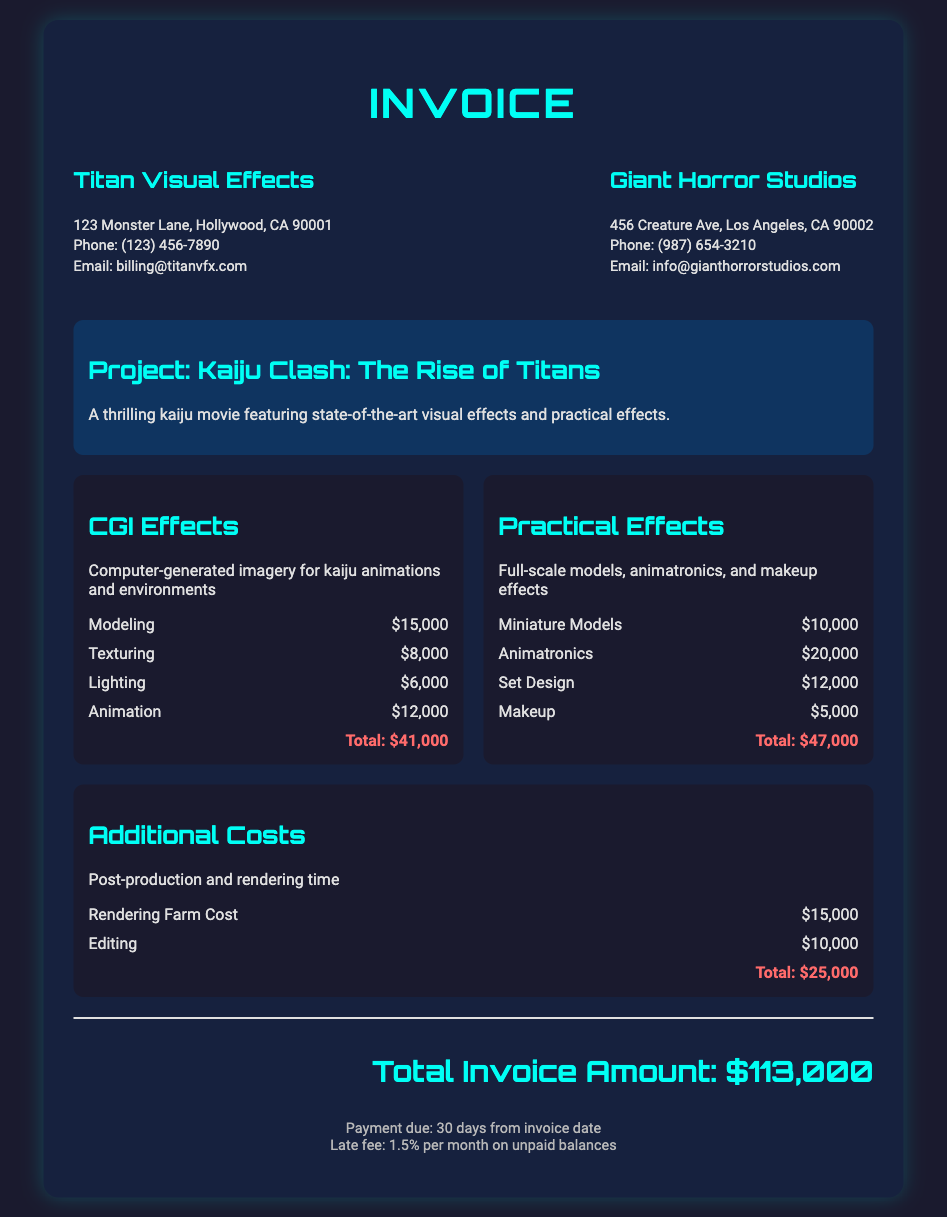What is the total amount for CGI effects? The total amount for CGI effects is stated in the cost category, which is $41,000.
Answer: $41,000 What is the name of the project? The project name is mentioned in the project information section as "Kaiju Clash: The Rise of Titans."
Answer: Kaiju Clash: The Rise of Titans How much was spent on animatronics? The amount spent on animatronics is listed under practical effects, which is $20,000.
Answer: $20,000 What is the grand total of the invoice? The grand total is found in the grand total section of the invoice, which sums up all costs to $113,000.
Answer: $113,000 What is the payment due period? The payment due period is specified in the terms section as "30 days from invoice date."
Answer: 30 days What is the cost for rendering farm? The cost for rendering farm is detailed as $15,000 in the additional costs section.
Answer: $15,000 How much is the late fee percentage for unpaid balances? The late fee percentage for unpaid balances is mentioned as 1.5% in the terms section.
Answer: 1.5% What type of effects does the practical effects category include? The practical effects category includes full-scale models, animatronics, and makeup effects, as stated in its description.
Answer: Full-scale models, animatronics, and makeup effects What is the total amount for additional costs? The total amount for additional costs is stated under that category as $25,000.
Answer: $25,000 